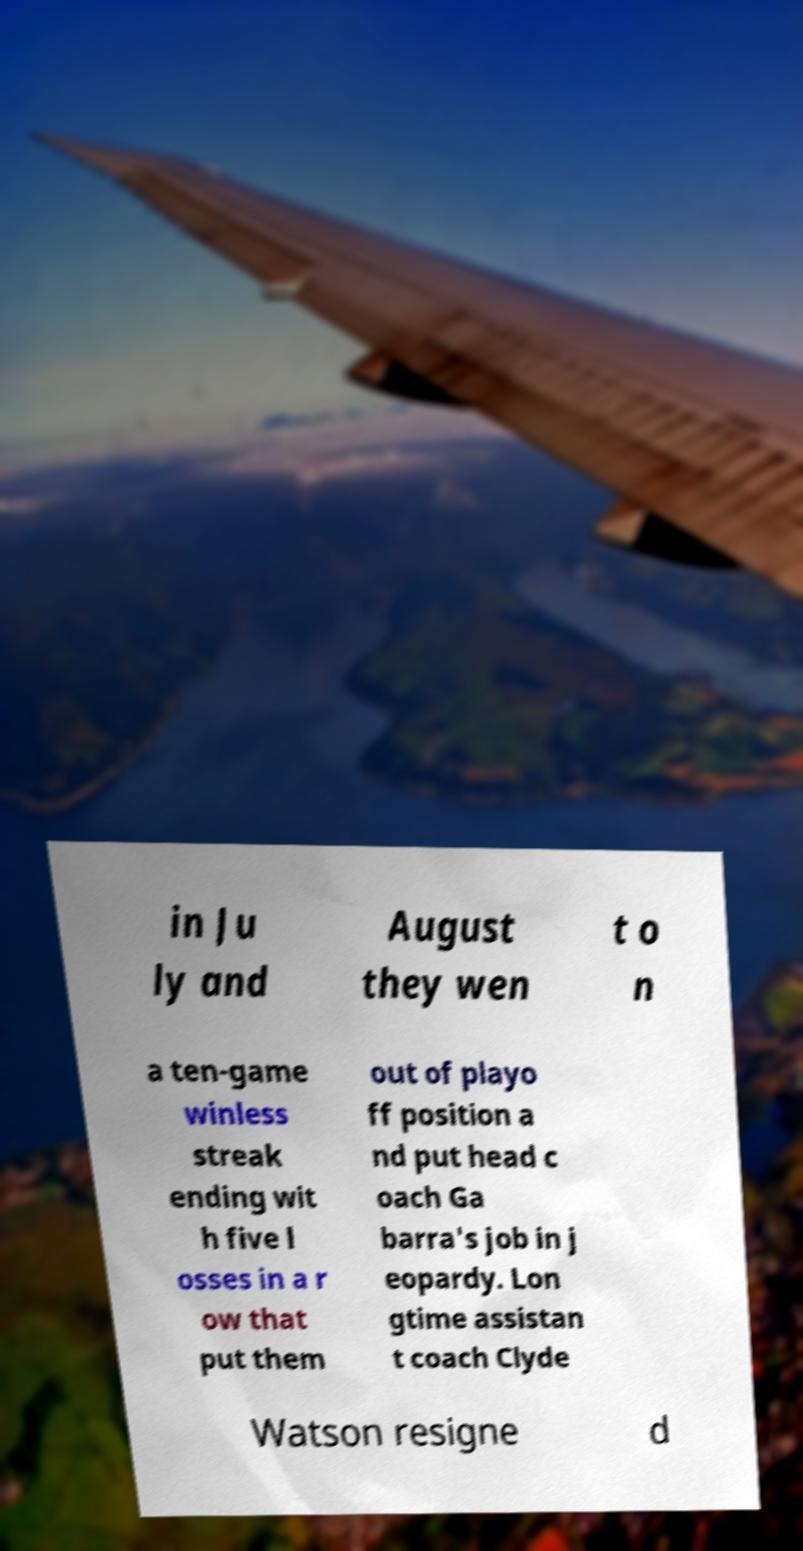Could you extract and type out the text from this image? in Ju ly and August they wen t o n a ten-game winless streak ending wit h five l osses in a r ow that put them out of playo ff position a nd put head c oach Ga barra's job in j eopardy. Lon gtime assistan t coach Clyde Watson resigne d 